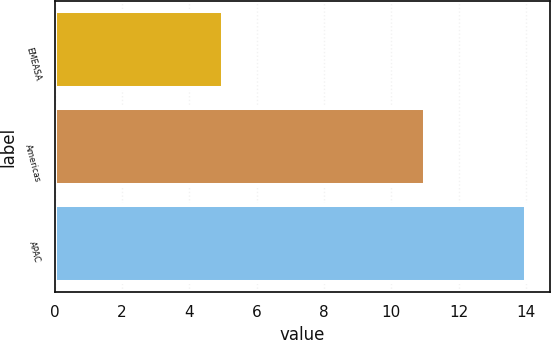Convert chart. <chart><loc_0><loc_0><loc_500><loc_500><bar_chart><fcel>EMEASA<fcel>Americas<fcel>APAC<nl><fcel>5<fcel>11<fcel>14<nl></chart> 